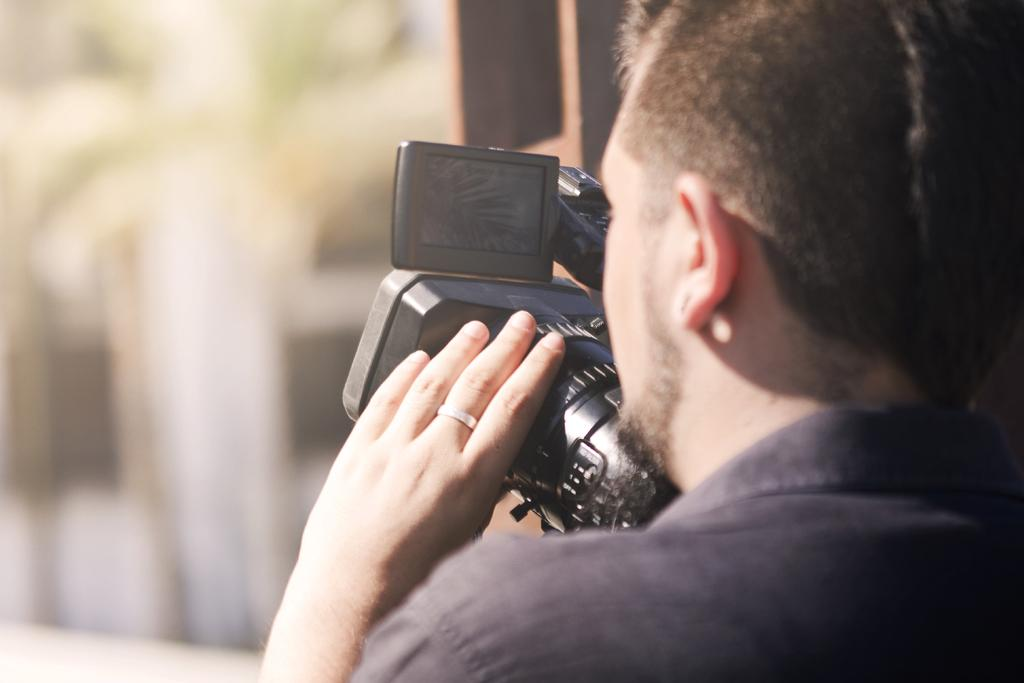Who is present in the image? There is a man in the image. What is the man holding in his hand? The man is holding a camera with his hand. Where is the toothbrush located in the image? There is no toothbrush present in the image. What type of stream can be seen in the background of the image? There is no stream visible in the image; it only features a man holding a camera. 